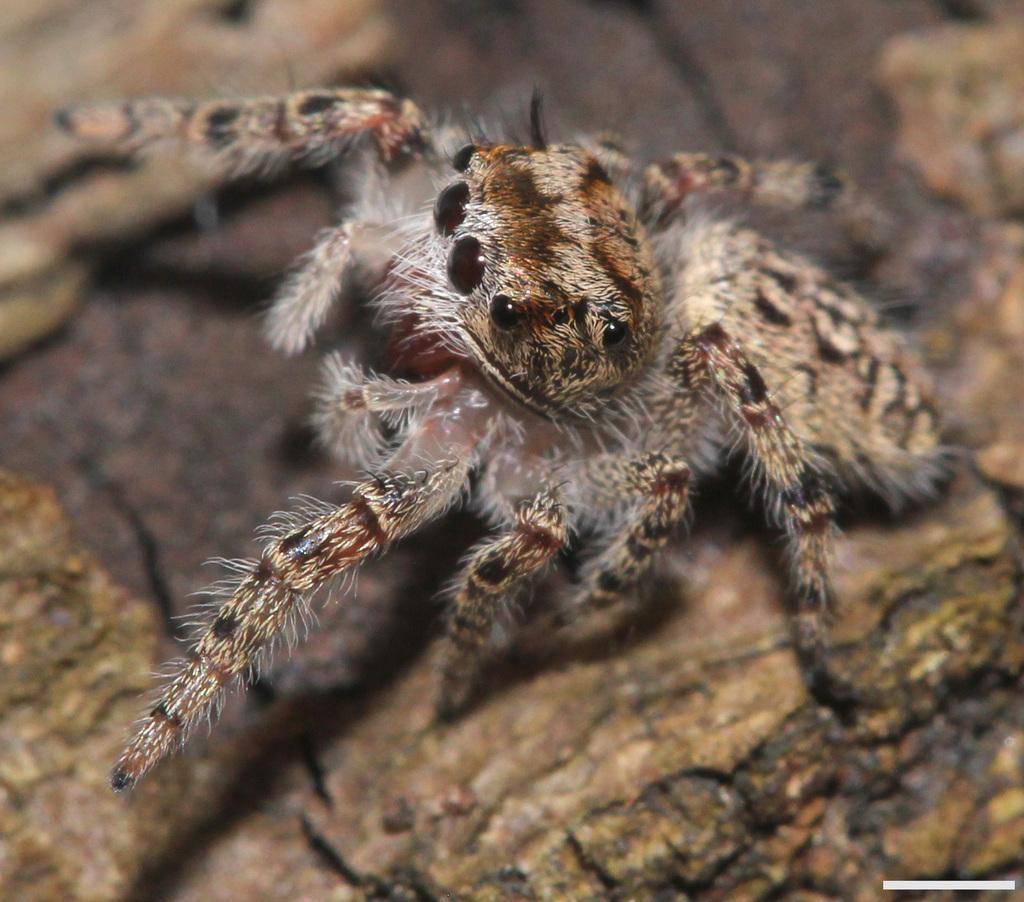Can you describe this image briefly? It is a zoomed in picture of a wolf spider. 